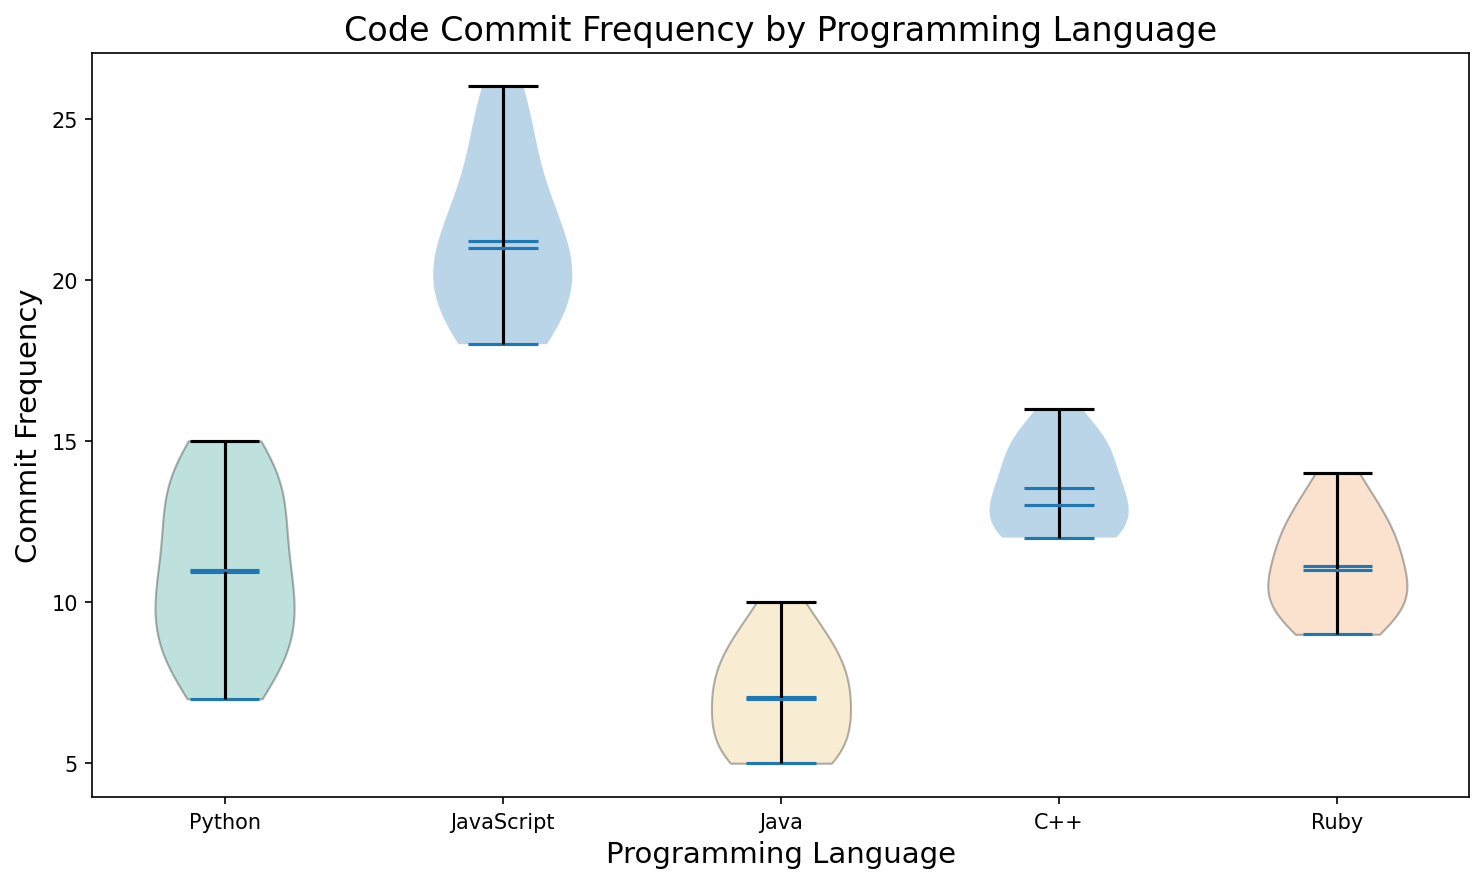What programming language has the widest range of commit frequencies? By inspecting the width of the violin plots, JavaScript has the widest range as its plot is spread out over a larger range of commit frequencies.
Answer: JavaScript What's the median commit frequency for Python? By looking at the plot for Python, the median line (horizontal line within the violin plot) lies at the value 11.
Answer: 11 Which programming language has the highest mean commit frequency? The mean is indicated by the dot in each violin plot. JavaScript has the highest mean commit frequency, as the dot is located highest among all the languages.
Answer: JavaScript Which programming languages have a mean commit frequency of around 10? By observing the position of the mean dots, Python, Ruby, and C++ all have means that are approximately around 10.
Answer: Python, Ruby, C++ How does the commit frequency distribution of Java compare to Ruby? Java's commit frequency distribution is more concentrated and lower in terms of range, while Ruby has a slightly higher range indicating some variability but overall is more consistent compared to Java.
Answer: Java has lower and more concentrated frequencies, Ruby is slightly more varied Between JavaScript and Ruby, which has a higher variability in commit frequency? JavaScript has a wider spread in its violin plot compared to Ruby, indicating higher variability in commit frequency.
Answer: JavaScript What's the interquartile range of commit frequencies for C++? The interquartile range spans between the 1st and 3rd quartile. For C++, the middle 50% of the data (indicated by the width of the violin) spans from 12 to 15.
Answer: 3 Compare the density at the median frequency for Python and JavaScript. Which is higher, and what does that indicate? The density at the median is indicated by the thickness of the plot at the median line. Python has a thicker area at the median frequency of 11 compared to JavaScript, suggesting more data points are concentrated around the median in Python.
Answer: Python How do the mean and median commit frequencies of Java compare? The median commit frequency for Java is around 7, while the mean is slightly higher, indicating possible positive skewness towards higher commit counts within its distribution.
Answer: Median ~ 7, Mean > 7 